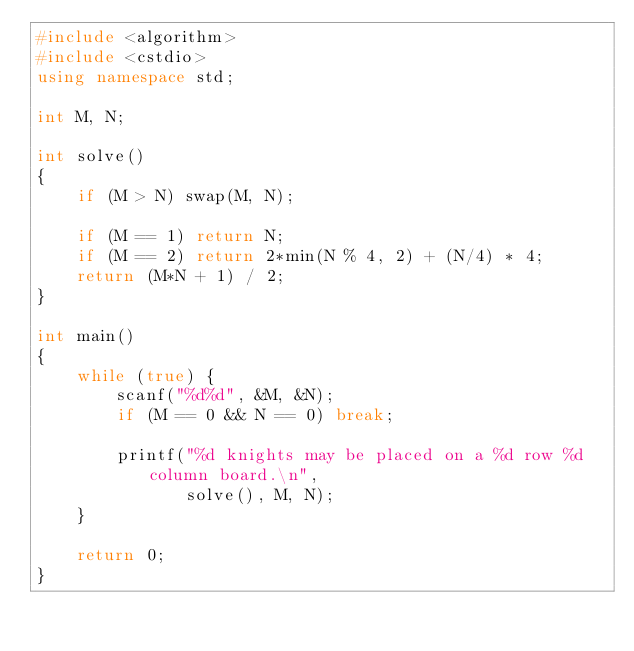Convert code to text. <code><loc_0><loc_0><loc_500><loc_500><_C++_>#include <algorithm>
#include <cstdio>
using namespace std;

int M, N;

int solve()
{
    if (M > N) swap(M, N);

    if (M == 1) return N;
    if (M == 2) return 2*min(N % 4, 2) + (N/4) * 4;
    return (M*N + 1) / 2;
}

int main()
{
    while (true) {
        scanf("%d%d", &M, &N);
        if (M == 0 && N == 0) break;

        printf("%d knights may be placed on a %d row %d column board.\n",
               solve(), M, N);
    }

    return 0;
}
</code> 